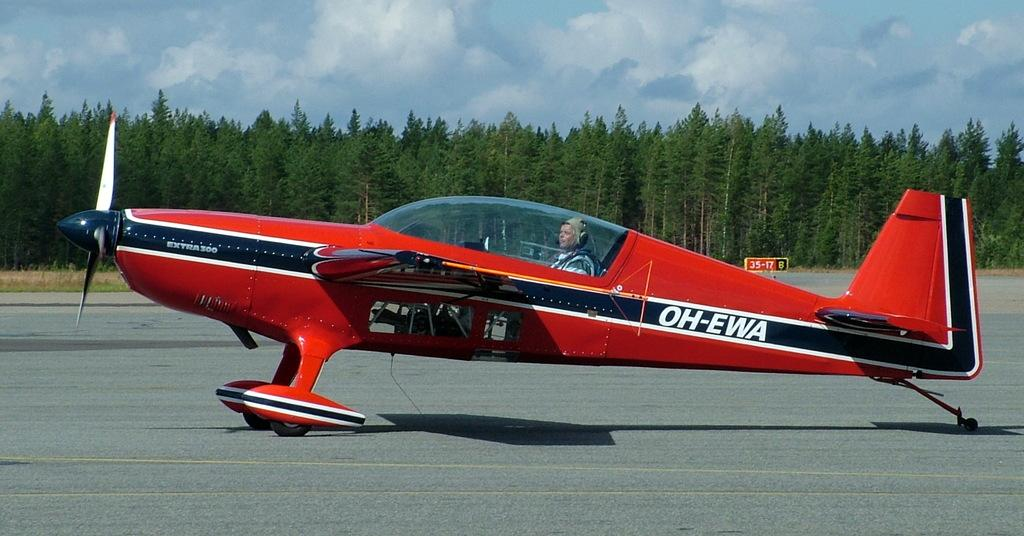<image>
Share a concise interpretation of the image provided. a plane that has the letters EWA on the side 